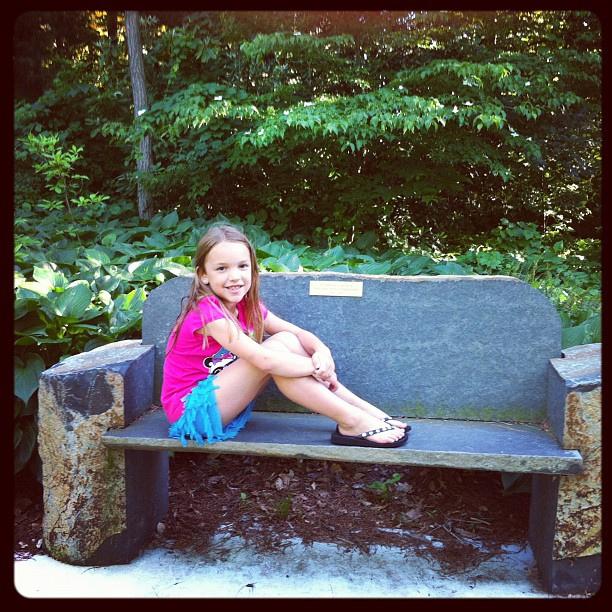Is this little girl wearing tennis shoes?
Be succinct. No. What is the bench made out of?
Short answer required. Stone. How many people are in the picture?
Short answer required. 1. 